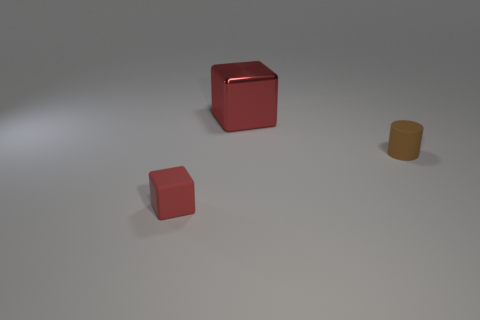Is there any other thing that is the same size as the metallic cube?
Provide a short and direct response. No. Is the large block the same color as the small matte block?
Your answer should be compact. Yes. Is there anything else that has the same shape as the brown object?
Offer a very short reply. No. There is another block that is the same color as the big metal cube; what is its material?
Your answer should be compact. Rubber. There is a brown matte thing that is the same size as the red rubber block; what is its shape?
Make the answer very short. Cylinder. There is a cube that is to the right of the tiny red rubber thing on the left side of the large metallic cube; is there a large red block that is left of it?
Offer a terse response. No. Is the color of the large metal cube the same as the rubber object that is left of the small brown cylinder?
Keep it short and to the point. Yes. What number of large things have the same color as the small matte cube?
Ensure brevity in your answer.  1. There is a matte thing behind the tiny object that is to the left of the big red metal object; what size is it?
Ensure brevity in your answer.  Small. How many objects are either tiny things left of the tiny brown cylinder or red matte cubes?
Offer a terse response. 1. 